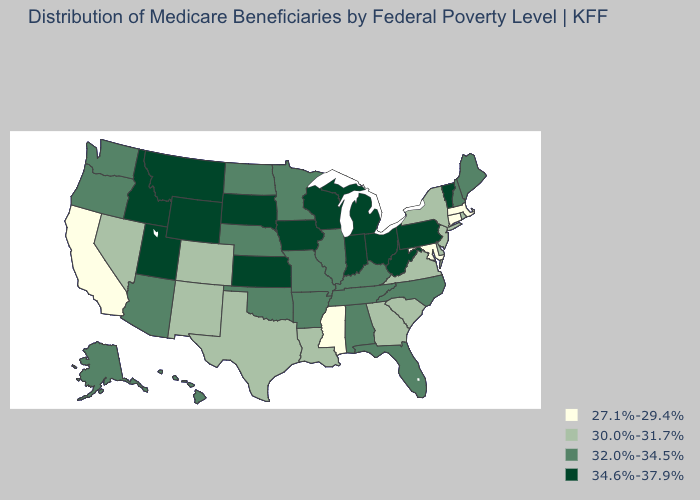What is the value of California?
Write a very short answer. 27.1%-29.4%. Does Hawaii have the highest value in the West?
Give a very brief answer. No. Which states have the lowest value in the USA?
Short answer required. California, Connecticut, Maryland, Massachusetts, Mississippi. Name the states that have a value in the range 34.6%-37.9%?
Quick response, please. Idaho, Indiana, Iowa, Kansas, Michigan, Montana, Ohio, Pennsylvania, South Dakota, Utah, Vermont, West Virginia, Wisconsin, Wyoming. Name the states that have a value in the range 34.6%-37.9%?
Keep it brief. Idaho, Indiana, Iowa, Kansas, Michigan, Montana, Ohio, Pennsylvania, South Dakota, Utah, Vermont, West Virginia, Wisconsin, Wyoming. Name the states that have a value in the range 30.0%-31.7%?
Be succinct. Colorado, Delaware, Georgia, Louisiana, Nevada, New Jersey, New Mexico, New York, Rhode Island, South Carolina, Texas, Virginia. Is the legend a continuous bar?
Concise answer only. No. Which states have the highest value in the USA?
Short answer required. Idaho, Indiana, Iowa, Kansas, Michigan, Montana, Ohio, Pennsylvania, South Dakota, Utah, Vermont, West Virginia, Wisconsin, Wyoming. Which states have the highest value in the USA?
Concise answer only. Idaho, Indiana, Iowa, Kansas, Michigan, Montana, Ohio, Pennsylvania, South Dakota, Utah, Vermont, West Virginia, Wisconsin, Wyoming. Does the map have missing data?
Short answer required. No. What is the lowest value in the South?
Quick response, please. 27.1%-29.4%. Does New Mexico have the highest value in the West?
Give a very brief answer. No. What is the value of Michigan?
Concise answer only. 34.6%-37.9%. Name the states that have a value in the range 32.0%-34.5%?
Keep it brief. Alabama, Alaska, Arizona, Arkansas, Florida, Hawaii, Illinois, Kentucky, Maine, Minnesota, Missouri, Nebraska, New Hampshire, North Carolina, North Dakota, Oklahoma, Oregon, Tennessee, Washington. What is the value of North Dakota?
Quick response, please. 32.0%-34.5%. 